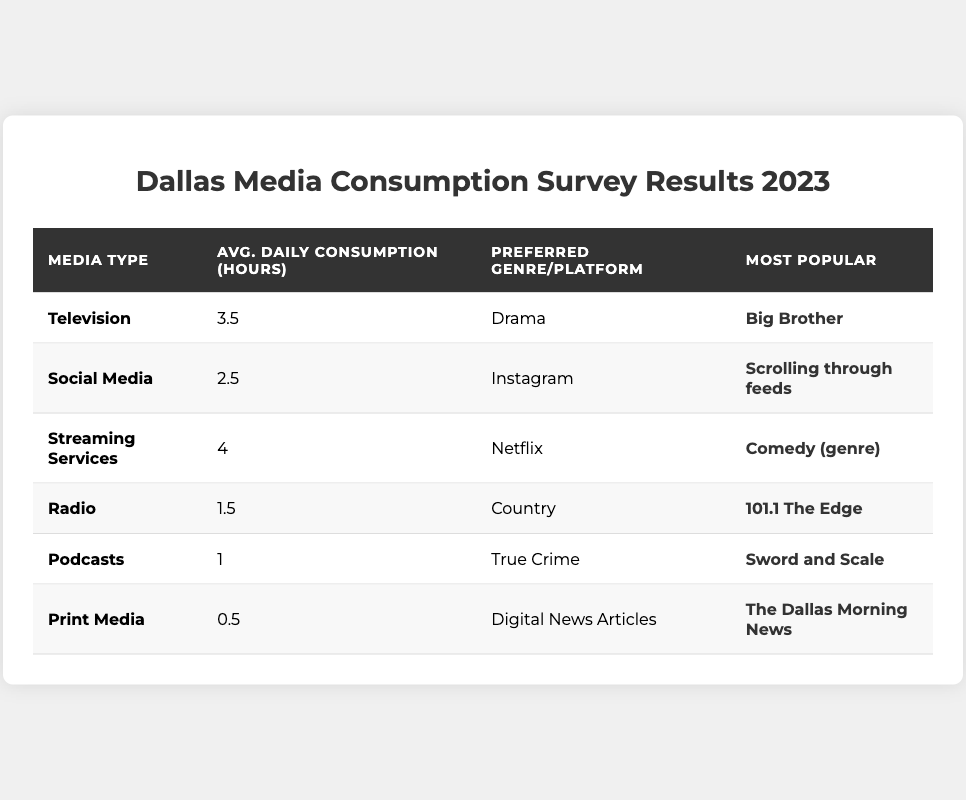What is the average daily consumption of television among Dallas residents? The table states that the average daily consumption of television is 3.5 hours.
Answer: 3.5 hours Which media type has the highest average daily consumption hours? Looking at the table, Streaming Services has the highest average daily consumption at 4 hours.
Answer: Streaming Services What is the preferred genre for radio among Dallas residents? The table indicates that the preferred genre for radio is Country.
Answer: Country How many hours on average do Dallas residents consume print media daily? According to the table, Dallas residents consume print media for 0.5 hours on average daily.
Answer: 0.5 hours Do more Dallas residents prefer to listen to podcasts than to the radio? The average daily consumption for podcasts is 1 hour, and for radio, it is 1.5 hours. Since 1 is less than 1.5, more residents prefer radio.
Answer: No What is the sum of average daily consumption hours for social media and podcasts? From the table, social media consumption is 2.5 hours and podcasts is 1 hour. Adding them gives 2.5 + 1 = 3.5 hours.
Answer: 3.5 hours What is the most popular show among television viewers in Dallas? The table states that the most popular show is "Big Brother."
Answer: Big Brother Which is the most common activity on social media according to the table? The most common activity on social media listed in the table is "Scrolling through feeds."
Answer: Scrolling through feeds What is the total average daily consumption of media (television, social media, streaming services, radio, podcasts, and print media)? To find the total, add all the average daily consumption hours: 3.5 + 2.5 + 4 + 1.5 + 1 + 0.5 = 13 hours.
Answer: 13 hours What is the preferred platform for streaming services among Dallas residents? According to the table, the preferred platform for streaming services is Netflix.
Answer: Netflix Which genre is preferred by residents for streaming services? The table indicates that the preferred genre for streaming services is Comedy.
Answer: Comedy Is 'The Dallas Morning News' the most read publication in print media? Yes, the table states that 'The Dallas Morning News' is the most read publication in print media.
Answer: Yes How many more hours do Dallas residents spend on streaming services than on podcasts? The average for streaming services is 4 hours, and for podcasts, it is 1 hour. The difference is 4 - 1 = 3 hours.
Answer: 3 hours What percentage of daily media consumption hours does print media represent? Total consumption is 13 hours. Print media is 0.5 hours, so (0.5/13) * 100 ≈ 3.85%.
Answer: 3.85% 